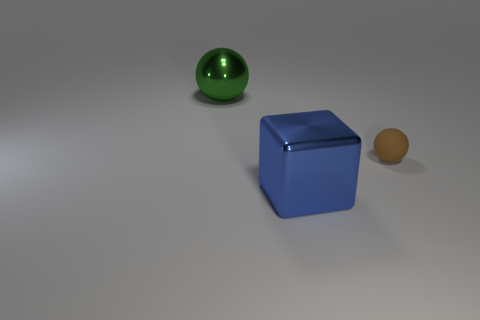Add 3 big green shiny cylinders. How many objects exist? 6 Subtract all spheres. How many objects are left? 1 Add 1 tiny blue cylinders. How many tiny blue cylinders exist? 1 Subtract 1 blue cubes. How many objects are left? 2 Subtract all purple blocks. Subtract all gray spheres. How many blocks are left? 1 Subtract all big shiny blocks. Subtract all small spheres. How many objects are left? 1 Add 1 metal objects. How many metal objects are left? 3 